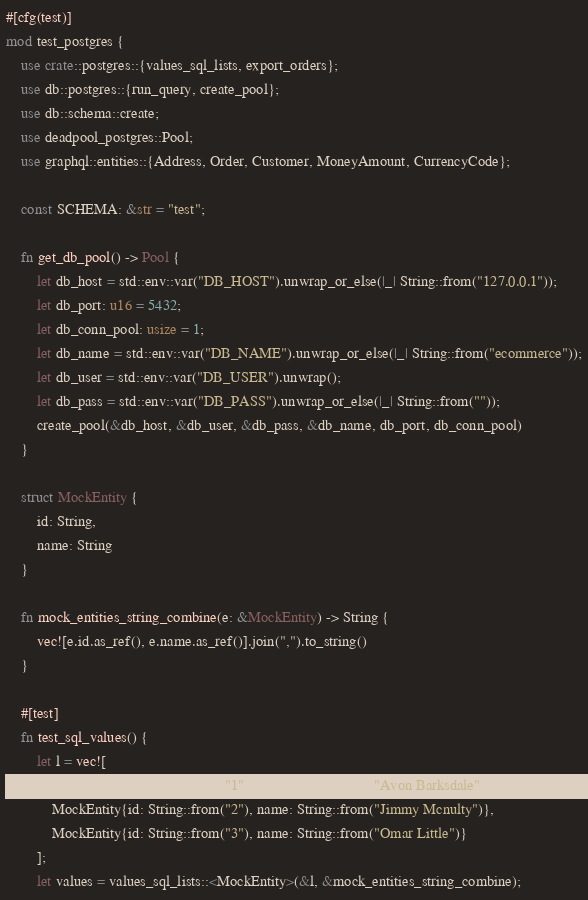Convert code to text. <code><loc_0><loc_0><loc_500><loc_500><_Rust_>#[cfg(test)]
mod test_postgres {
    use crate::postgres::{values_sql_lists, export_orders};
    use db::postgres::{run_query, create_pool};
    use db::schema::create;
    use deadpool_postgres::Pool;
    use graphql::entities::{Address, Order, Customer, MoneyAmount, CurrencyCode};

    const SCHEMA: &str = "test";

    fn get_db_pool() -> Pool {
        let db_host = std::env::var("DB_HOST").unwrap_or_else(|_| String::from("127.0.0.1"));
        let db_port: u16 = 5432;
        let db_conn_pool: usize = 1;
        let db_name = std::env::var("DB_NAME").unwrap_or_else(|_| String::from("ecommerce"));
        let db_user = std::env::var("DB_USER").unwrap();
        let db_pass = std::env::var("DB_PASS").unwrap_or_else(|_| String::from(""));
        create_pool(&db_host, &db_user, &db_pass, &db_name, db_port, db_conn_pool)
    }

    struct MockEntity {
        id: String,
        name: String
    }

    fn mock_entities_string_combine(e: &MockEntity) -> String {
        vec![e.id.as_ref(), e.name.as_ref()].join(",").to_string()
    }

    #[test]
    fn test_sql_values() {
        let l = vec![
            MockEntity{id: String::from("1"), name: String::from("Avon Barksdale")},
            MockEntity{id: String::from("2"), name: String::from("Jimmy Mcnulty")},
            MockEntity{id: String::from("3"), name: String::from("Omar Little")}
        ];
        let values = values_sql_lists::<MockEntity>(&l, &mock_entities_string_combine);</code> 